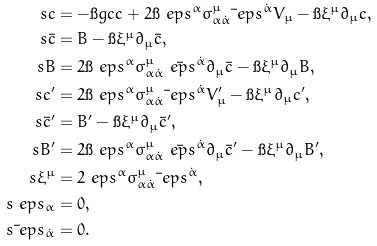Convert formula to latex. <formula><loc_0><loc_0><loc_500><loc_500>\ s c & = - \i g c c + 2 \i \ e p s ^ { \alpha } \sigma ^ { \mu } _ { \alpha \dot { \alpha } } \bar { \ } e p s ^ { \dot { \alpha } } V _ { \mu } - \i \xi ^ { \mu } \partial _ { \mu } c , \\ \ s \bar { c } & = B - \i \xi ^ { \mu } \partial _ { \mu } \bar { c } , \\ \ s B & = 2 \i \ e p s ^ { \alpha } \sigma ^ { \mu } _ { \alpha \dot { \alpha } } \bar { \ e p s } ^ { \dot { \alpha } } \partial _ { \mu } \bar { c } - \i \xi ^ { \mu } \partial _ { \mu } B , \\ \ s c ^ { \prime } & = 2 \i \ e p s ^ { \alpha } \sigma ^ { \mu } _ { \alpha \dot { \alpha } } \bar { \ } e p s ^ { \dot { \alpha } } V _ { \mu } ^ { \prime } - \i \xi ^ { \mu } \partial _ { \mu } c ^ { \prime } , \\ \ s \bar { c } ^ { \prime } & = B ^ { \prime } - \i \xi ^ { \mu } \partial _ { \mu } \bar { c } ^ { \prime } , \\ \ s B ^ { \prime } & = 2 \i \ e p s ^ { \alpha } \sigma ^ { \mu } _ { \alpha \dot { \alpha } } \bar { \ e p s } ^ { \dot { \alpha } } \partial _ { \mu } \bar { c } ^ { \prime } - \i \xi ^ { \mu } \partial _ { \mu } B ^ { \prime } , \\ \ s \xi ^ { \mu } & = 2 \ e p s ^ { \alpha } \sigma ^ { \mu } _ { \alpha \dot { \alpha } } \bar { \ } e p s ^ { \dot { \alpha } } , \\ \ s \ e p s _ { \alpha } & = 0 , \\ \ s \bar { \ } e p s _ { \dot { \alpha } } & = 0 .</formula> 